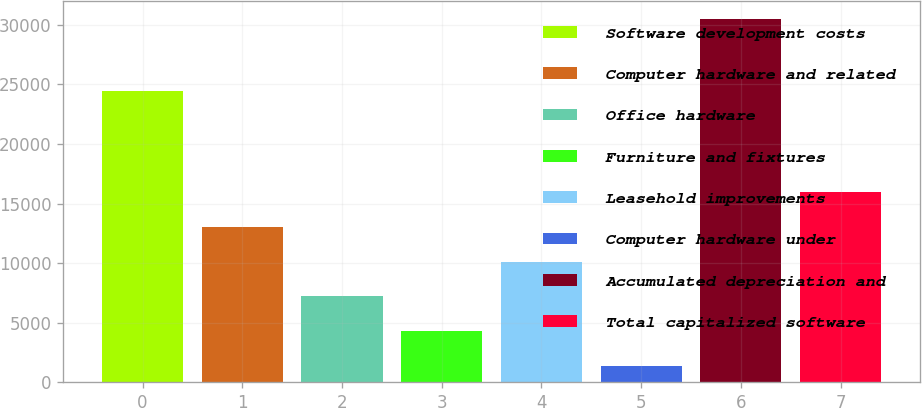Convert chart. <chart><loc_0><loc_0><loc_500><loc_500><bar_chart><fcel>Software development costs<fcel>Computer hardware and related<fcel>Office hardware<fcel>Furniture and fixtures<fcel>Leasehold improvements<fcel>Computer hardware under<fcel>Accumulated depreciation and<fcel>Total capitalized software<nl><fcel>24440<fcel>13039.4<fcel>7229.2<fcel>4324.1<fcel>10134.3<fcel>1419<fcel>30470<fcel>15944.5<nl></chart> 